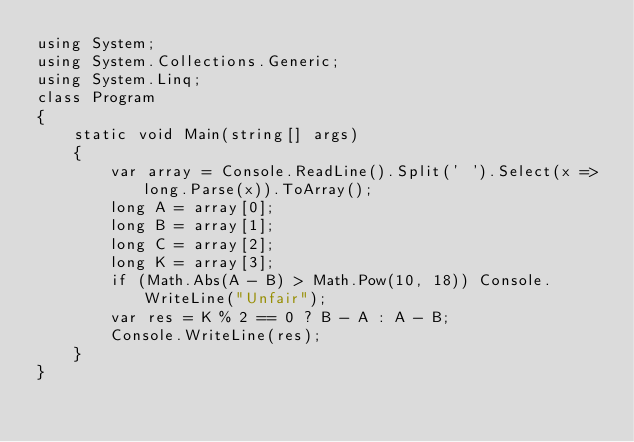Convert code to text. <code><loc_0><loc_0><loc_500><loc_500><_C#_>using System;
using System.Collections.Generic;
using System.Linq;
class Program
{
    static void Main(string[] args)
    {
        var array = Console.ReadLine().Split(' ').Select(x => long.Parse(x)).ToArray();
        long A = array[0];
        long B = array[1];
        long C = array[2];
        long K = array[3];
        if (Math.Abs(A - B) > Math.Pow(10, 18)) Console.WriteLine("Unfair");
        var res = K % 2 == 0 ? B - A : A - B;
        Console.WriteLine(res);
    }
}</code> 